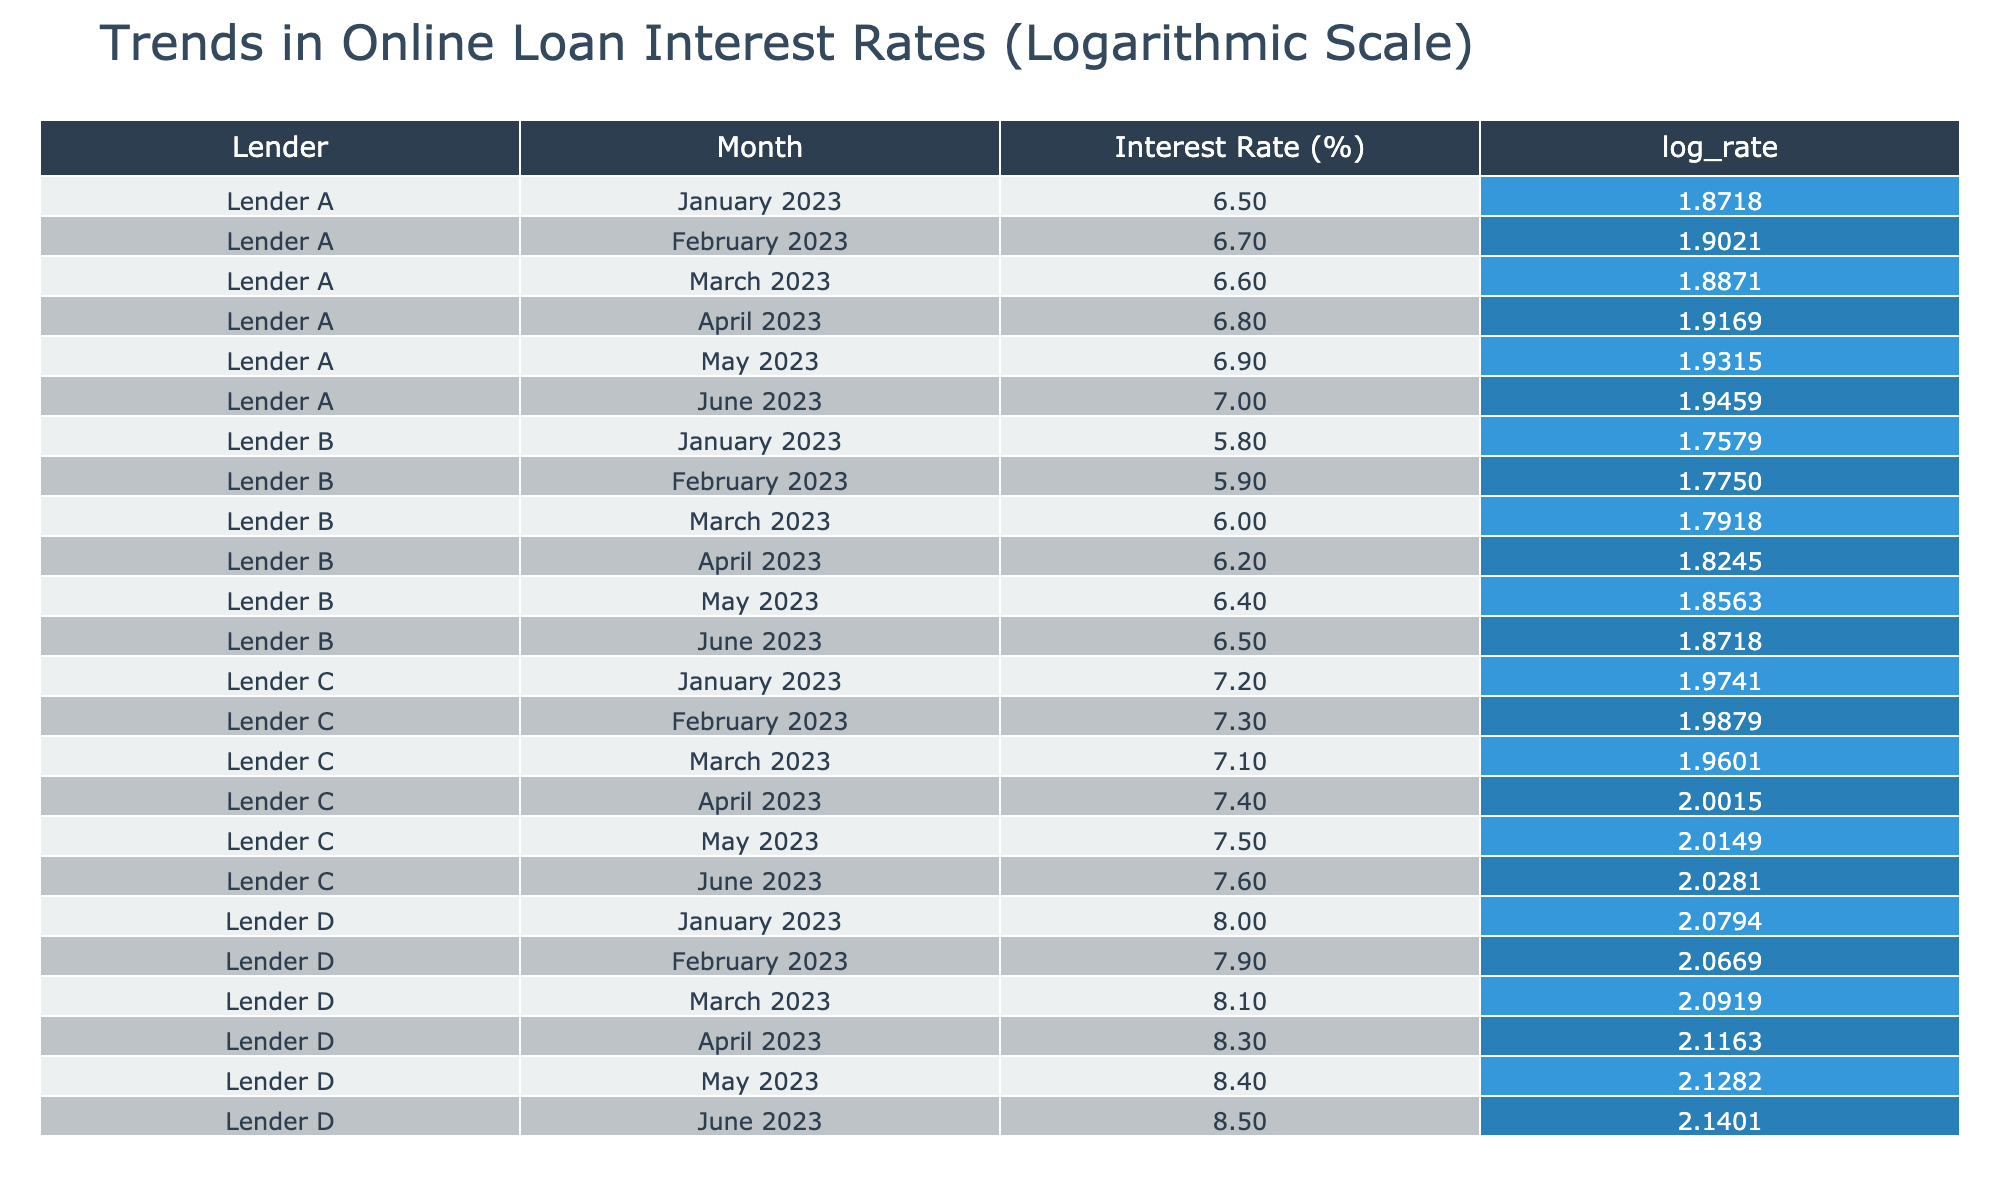What was the highest interest rate offered by Lender D? By looking at the data for Lender D, the interest rates listed for each month are January (8.0%), February (7.9%), March (8.1%), April (8.3%), May (8.4%), and June (8.5%). The highest value among these is 8.5% in June.
Answer: 8.5% Which lender had the lowest interest rate in January 2023? In January 2023, the interest rates for each lender are: Lender A (6.5%), Lender B (5.8%), Lender C (7.2%), and Lender D (8.0%). Lender B offers the lowest rate at 5.8%.
Answer: Lender B What is the average interest rate for Lender A from January to June 2023? To find the average interest rate for Lender A, we sum the interest rates from January to June: (6.5 + 6.7 + 6.6 + 6.8 + 6.9 + 7.0) = 40.5%. There are 6 months, so we divide 40.5% by 6, which equals 6.75%.
Answer: 6.75% Did Lender C's interest rate ever exceed Lender A's during the six months? Reviewing the interest rates month-by-month: Lender A's rates are 6.5%, 6.7%, 6.6%, 6.8%, 6.9%, 7.0%, while Lender C has 7.2%, 7.3%, 7.1%, 7.4%, 7.5%, 7.6%. Each month, Lender C's rate is consistently higher than Lender A's. Thus, Lender C's rate always exceeds Lender A's.
Answer: Yes What was the change in Lender B's interest rate from January to June 2023? The interest rate for Lender B in January is 5.8% and in June it is 6.5%. The change is calculated by subtracting January's rate from June's rate: 6.5% - 5.8% = 0.7%. This indicates an increase.
Answer: 0.7% increase 